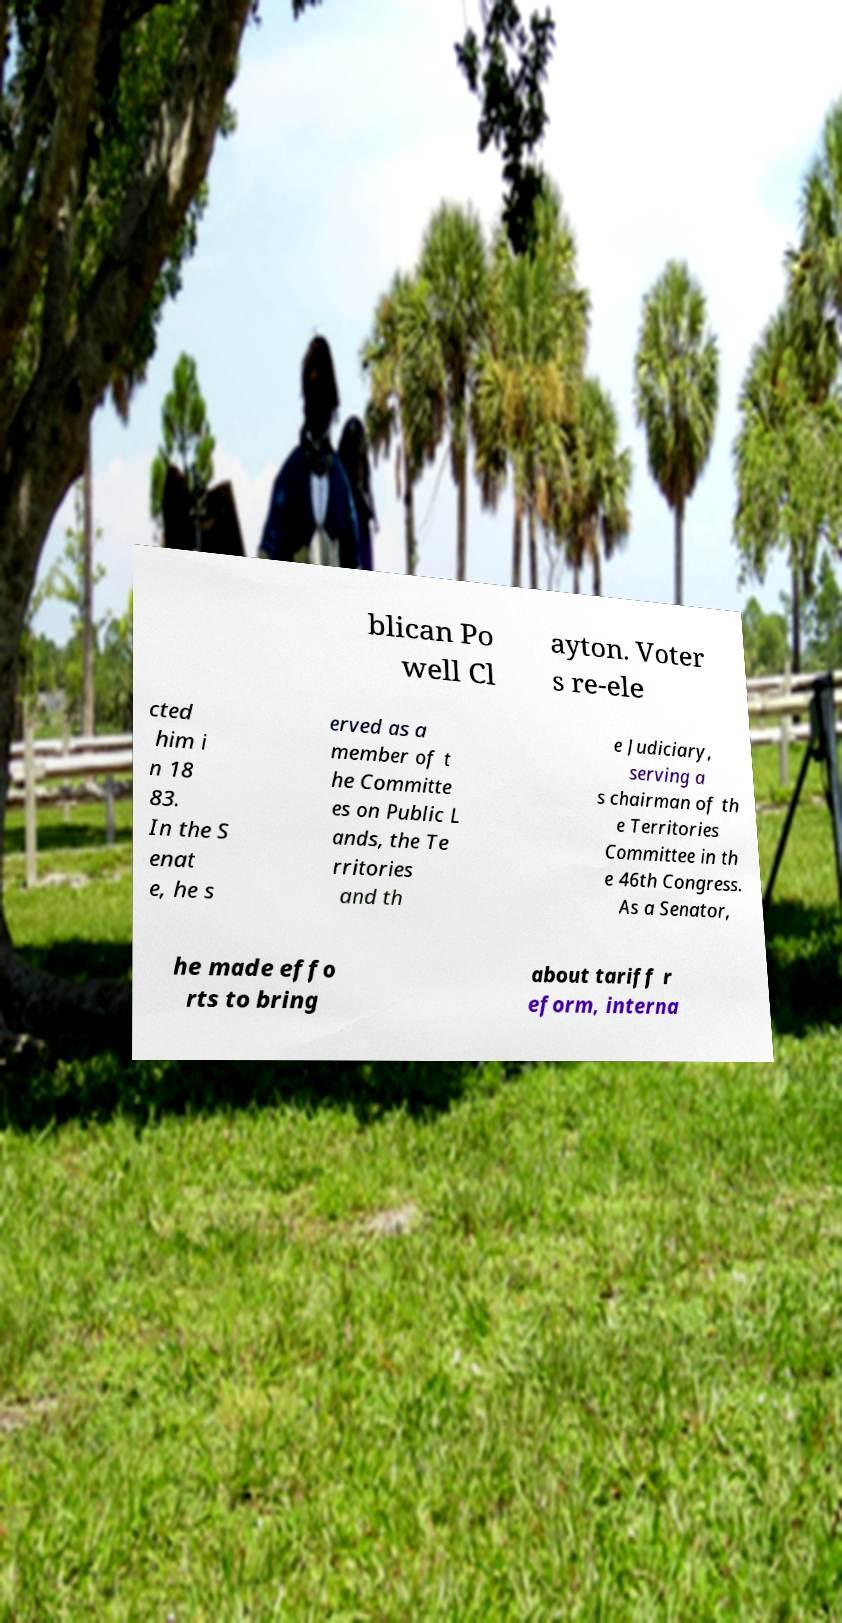There's text embedded in this image that I need extracted. Can you transcribe it verbatim? blican Po well Cl ayton. Voter s re-ele cted him i n 18 83. In the S enat e, he s erved as a member of t he Committe es on Public L ands, the Te rritories and th e Judiciary, serving a s chairman of th e Territories Committee in th e 46th Congress. As a Senator, he made effo rts to bring about tariff r eform, interna 